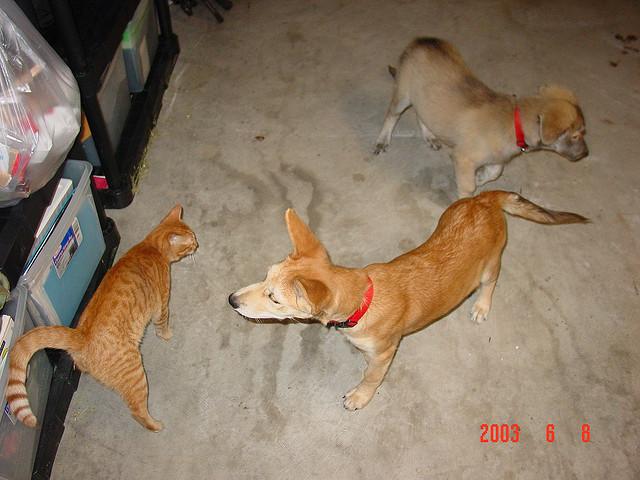What is next to this dog?
Write a very short answer. Cat. Is the cat wearing a collar?
Be succinct. No. How many cats are there?
Keep it brief. 1. What date is shown in the picture?
Keep it brief. 6/8/2003. How many dogs do you see?
Write a very short answer. 2. Are the animals standing on carpet?
Be succinct. Yes. How many dogs are actually there?
Answer briefly. 2. 